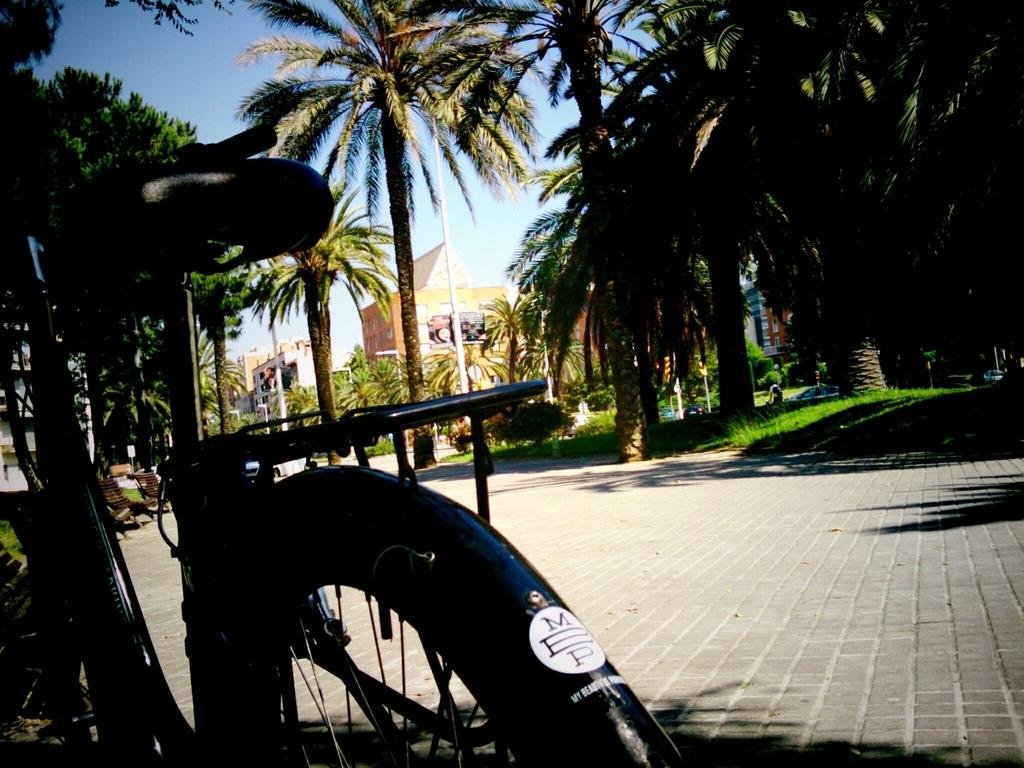What is the main object in the front of the image? There is a bicycle in the front of the image. What can be seen in the background of the image? There are trees and buildings in the background of the image. What type of terrain is visible in the image? There is grass on the ground in the image. What type of flame can be seen on the bicycle in the image? There is no flame present on the bicycle in the image. Is there a mask hanging from the handlebars of the bicycle in the image? There is no mask visible on the bicycle or anywhere else in the image. 